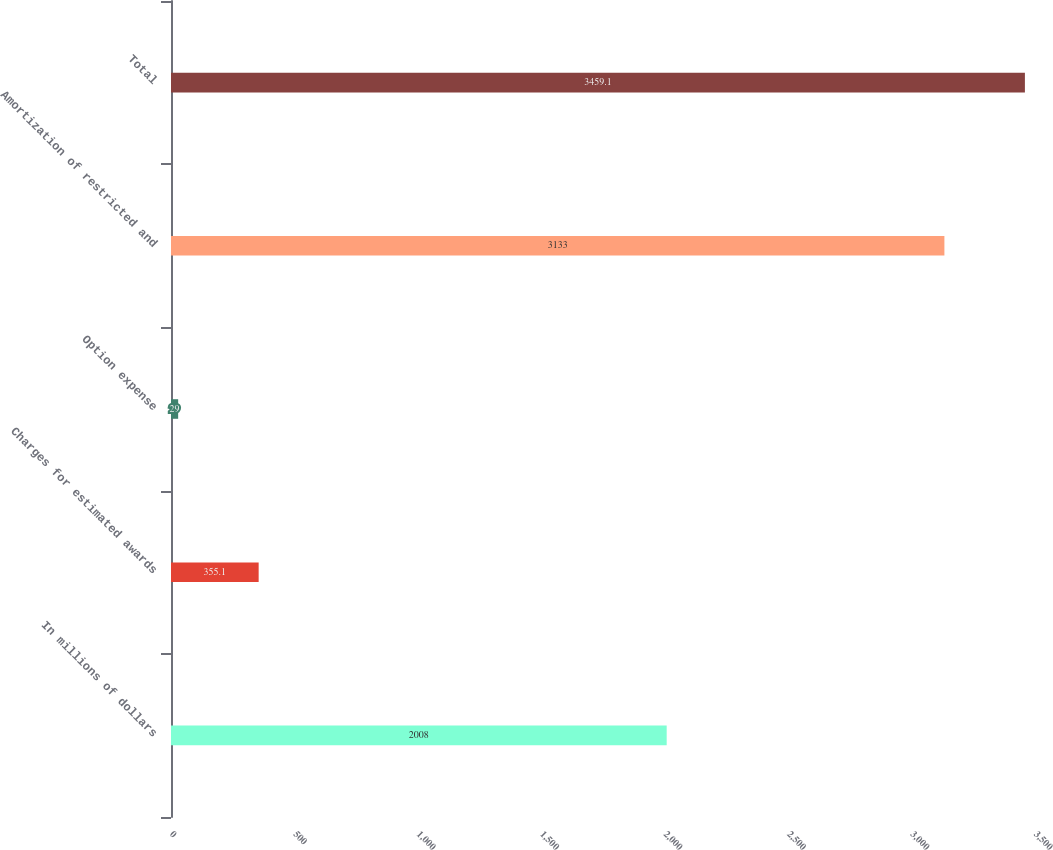Convert chart. <chart><loc_0><loc_0><loc_500><loc_500><bar_chart><fcel>In millions of dollars<fcel>Charges for estimated awards<fcel>Option expense<fcel>Amortization of restricted and<fcel>Total<nl><fcel>2008<fcel>355.1<fcel>29<fcel>3133<fcel>3459.1<nl></chart> 